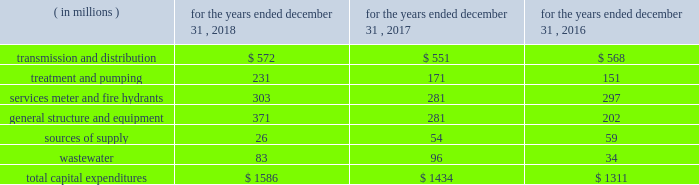The table provides a summary of our historical capital expenditures related to the upgrading of our infrastructure and systems: .
In 2018 , our capital expenditures increased $ 152 million , or 10.6% ( 10.6 % ) , primarily due to investment across the majority of our infrastructure categories .
In 2017 , our capital expenditures increased $ 123 million , or 9.4% ( 9.4 % ) , primarily due to investment in our general structure and equipment and wastewater categories .
We also grow our business primarily through acquisitions of water and wastewater systems , as well as other water-related services .
These acquisitions are complementary to our existing business and support continued geographical diversification and growth of our operations .
Generally , acquisitions are funded initially with short- term debt , and later refinanced with the proceeds from long-term debt .
The following is a summary of the acquisitions and dispositions affecting our cash flows from investing activities : 2022 the majority of cash paid for acquisitions pertained to the $ 365 million purchase of pivotal within our homeowner services group .
2022 paid $ 33 million for 15 water and wastewater systems , representing approximately 14000 customers .
2022 received $ 35 million for the sale of assets , including $ 27 million for the sale of the majority of the o&m contracts in our contract services group during the third quarter of 2018 .
2022 the majority of cash paid for acquisitions pertained to the $ 159 million purchase of the wastewater collection and treatment system assets of the municipal authority of the city of mckeesport , pennsylvania ( the 201cmckeesport system 201d ) , excluding a $ 5 million non-escrowed deposit made in 2016 .
2022 paid $ 18 million for 16 water and wastewater systems , excluding the mckeesport system and shorelands ( a stock-for-stock transaction ) , representing approximately 7000 customers .
2022 received $ 15 million for the sale of assets .
2022 paid $ 199 million for 15 water and wastewater systems , representing approximately 42000 customers .
2022 made a non-escrowed deposit of $ 5 million related to the mckeesport system acquisition .
2022 received $ 9 million for the sale of assets .
As previously noted , we expect to invest between $ 8.0 billion to $ 8.6 billion from 2019 to 2023 , with $ 7.3 billion of this range for infrastructure improvements in our regulated businesses .
In 2019 , we expect to .
What percentage of total capital expenditures were related to general structure and equipment in 2018? 
Computations: (371 / 1586)
Answer: 0.23392. 